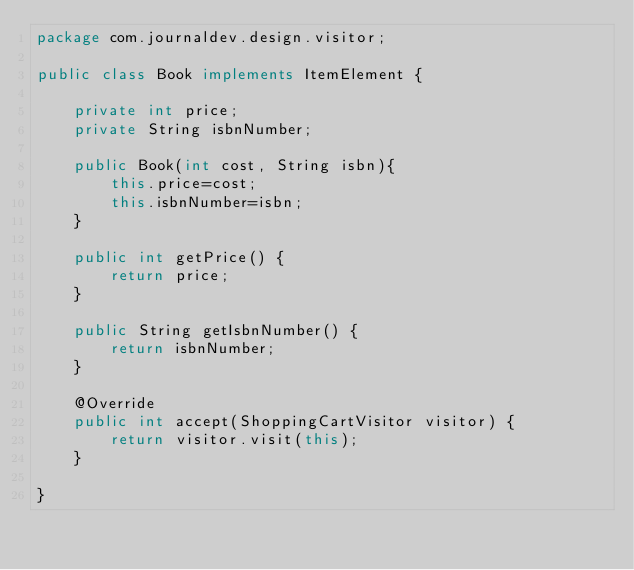<code> <loc_0><loc_0><loc_500><loc_500><_Java_>package com.journaldev.design.visitor;
 
public class Book implements ItemElement {
 
    private int price;
    private String isbnNumber;
     
    public Book(int cost, String isbn){
        this.price=cost;
        this.isbnNumber=isbn;
    }
     
    public int getPrice() {
        return price;
    }
 
    public String getIsbnNumber() {
        return isbnNumber;
    }
 
    @Override
    public int accept(ShoppingCartVisitor visitor) {
        return visitor.visit(this);
    }
 
}</code> 